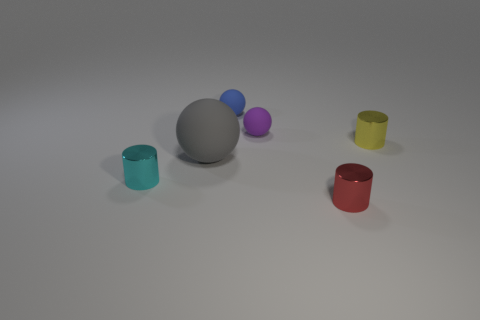Do the big matte thing and the metal object that is behind the cyan metallic cylinder have the same color?
Give a very brief answer. No. What shape is the tiny object that is both in front of the purple thing and on the left side of the purple object?
Give a very brief answer. Cylinder. What number of balls are there?
Keep it short and to the point. 3. The cyan shiny object that is the same shape as the red metallic object is what size?
Make the answer very short. Small. Does the rubber object in front of the tiny yellow shiny cylinder have the same shape as the yellow metal object?
Make the answer very short. No. What color is the rubber sphere behind the small purple ball?
Your answer should be very brief. Blue. What number of other things are the same size as the blue thing?
Make the answer very short. 4. Is there any other thing that has the same shape as the large rubber thing?
Ensure brevity in your answer.  Yes. Are there an equal number of tiny metal things behind the small cyan object and cylinders?
Your answer should be compact. No. What number of big cyan blocks are made of the same material as the yellow cylinder?
Your answer should be compact. 0. 